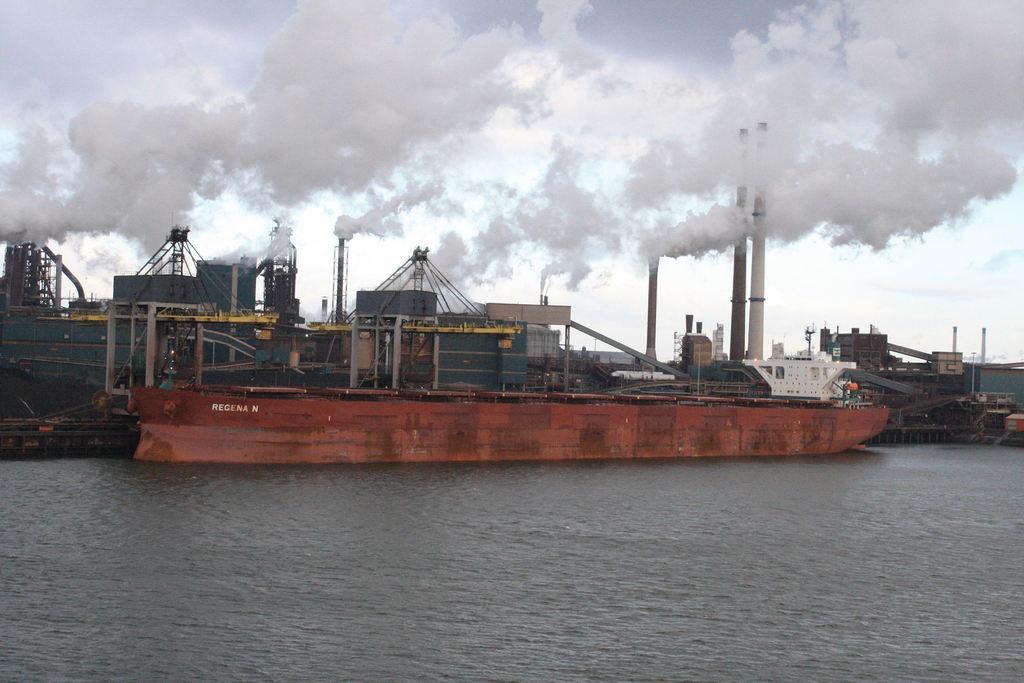How would you summarize this image in a sentence or two? In this image I can see many ships. These ships are in white, brown and grey color. These are on the water. In the background I can see the smoke, clouds and the white sky. 